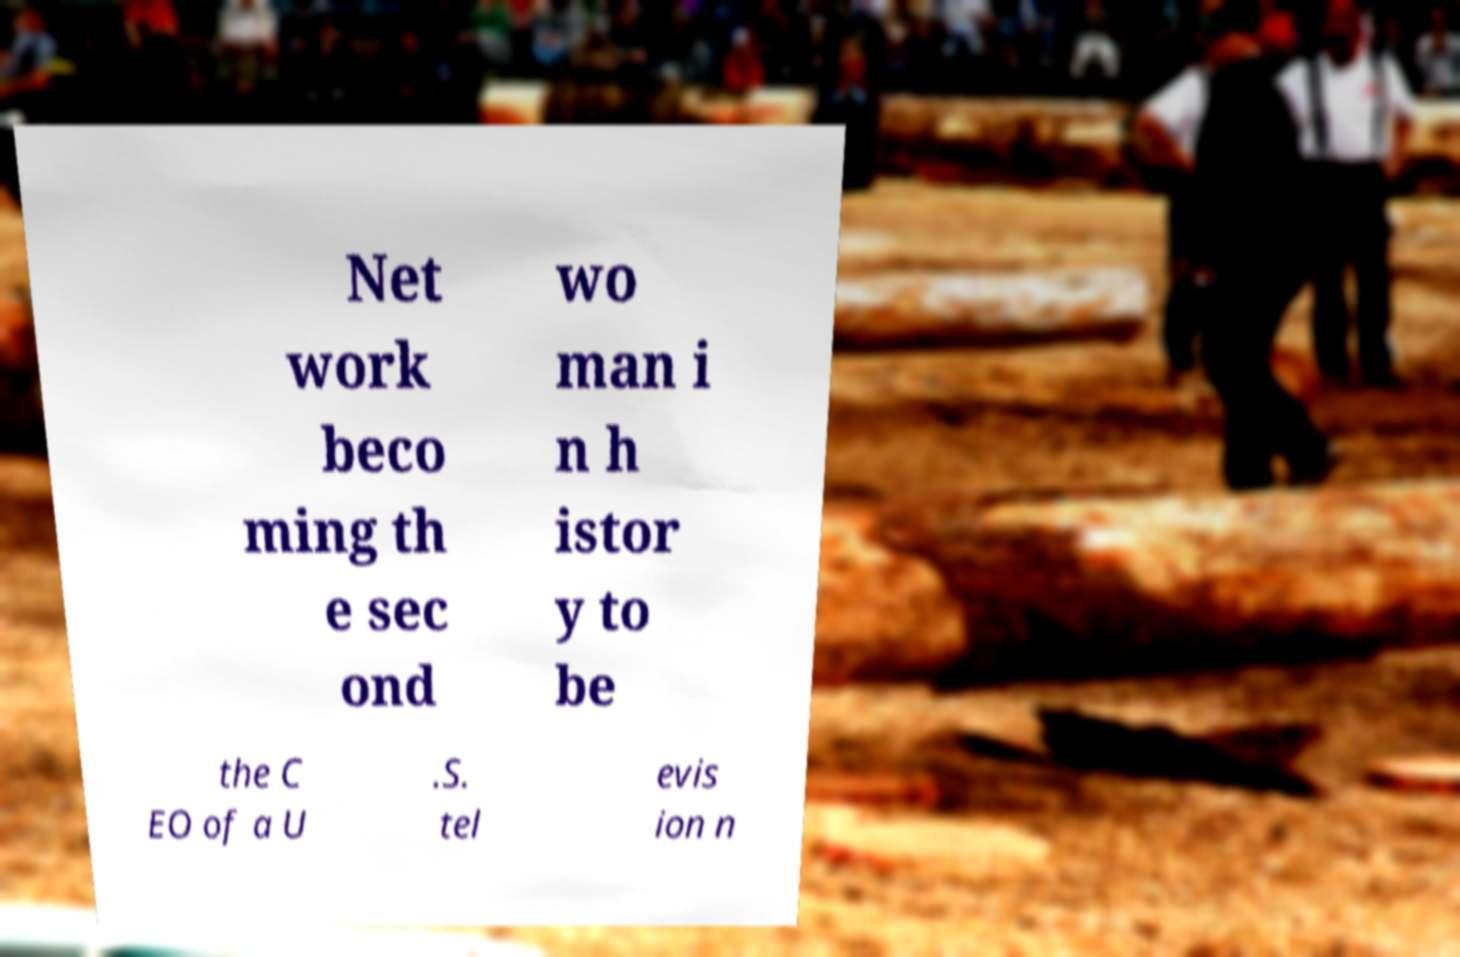Please identify and transcribe the text found in this image. Net work beco ming th e sec ond wo man i n h istor y to be the C EO of a U .S. tel evis ion n 